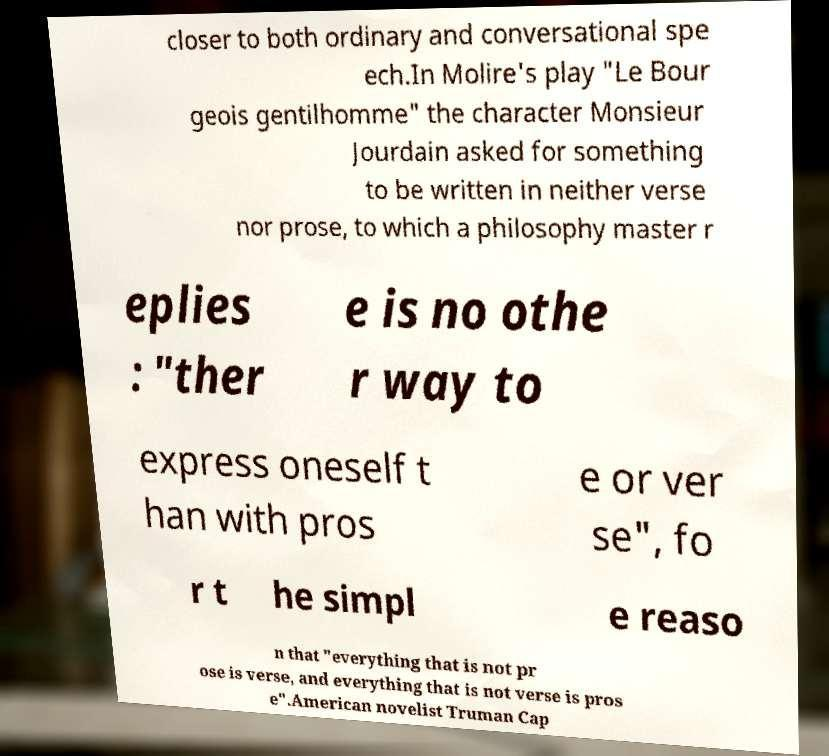There's text embedded in this image that I need extracted. Can you transcribe it verbatim? closer to both ordinary and conversational spe ech.In Molire's play "Le Bour geois gentilhomme" the character Monsieur Jourdain asked for something to be written in neither verse nor prose, to which a philosophy master r eplies : "ther e is no othe r way to express oneself t han with pros e or ver se", fo r t he simpl e reaso n that "everything that is not pr ose is verse, and everything that is not verse is pros e".American novelist Truman Cap 